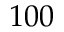<formula> <loc_0><loc_0><loc_500><loc_500>1 0 0</formula> 